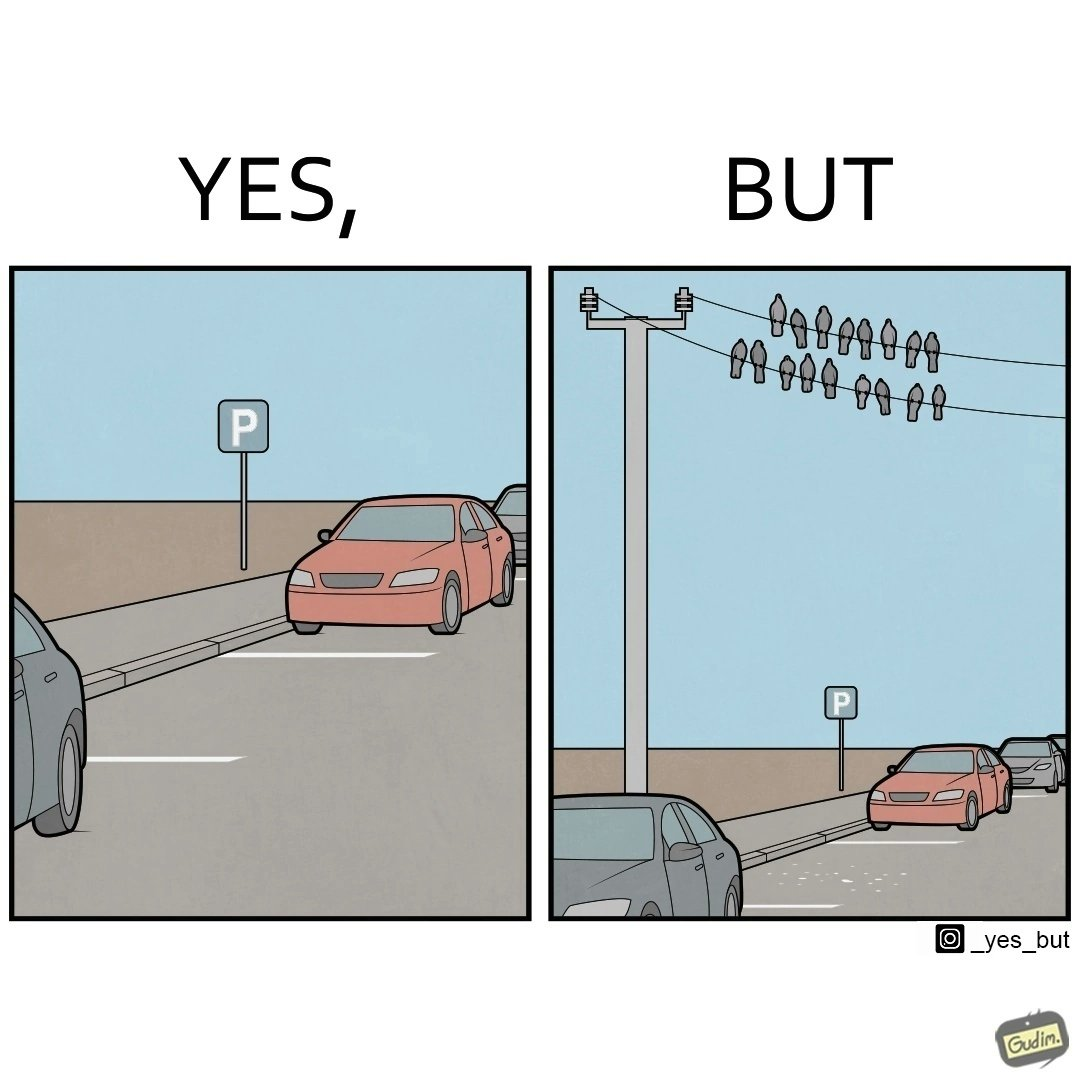Explain why this image is satirical. The image is ironical such that although there is a place for parking but that place is not suitable because if we place our car there then our car will become dirty from top due to crow beet. 